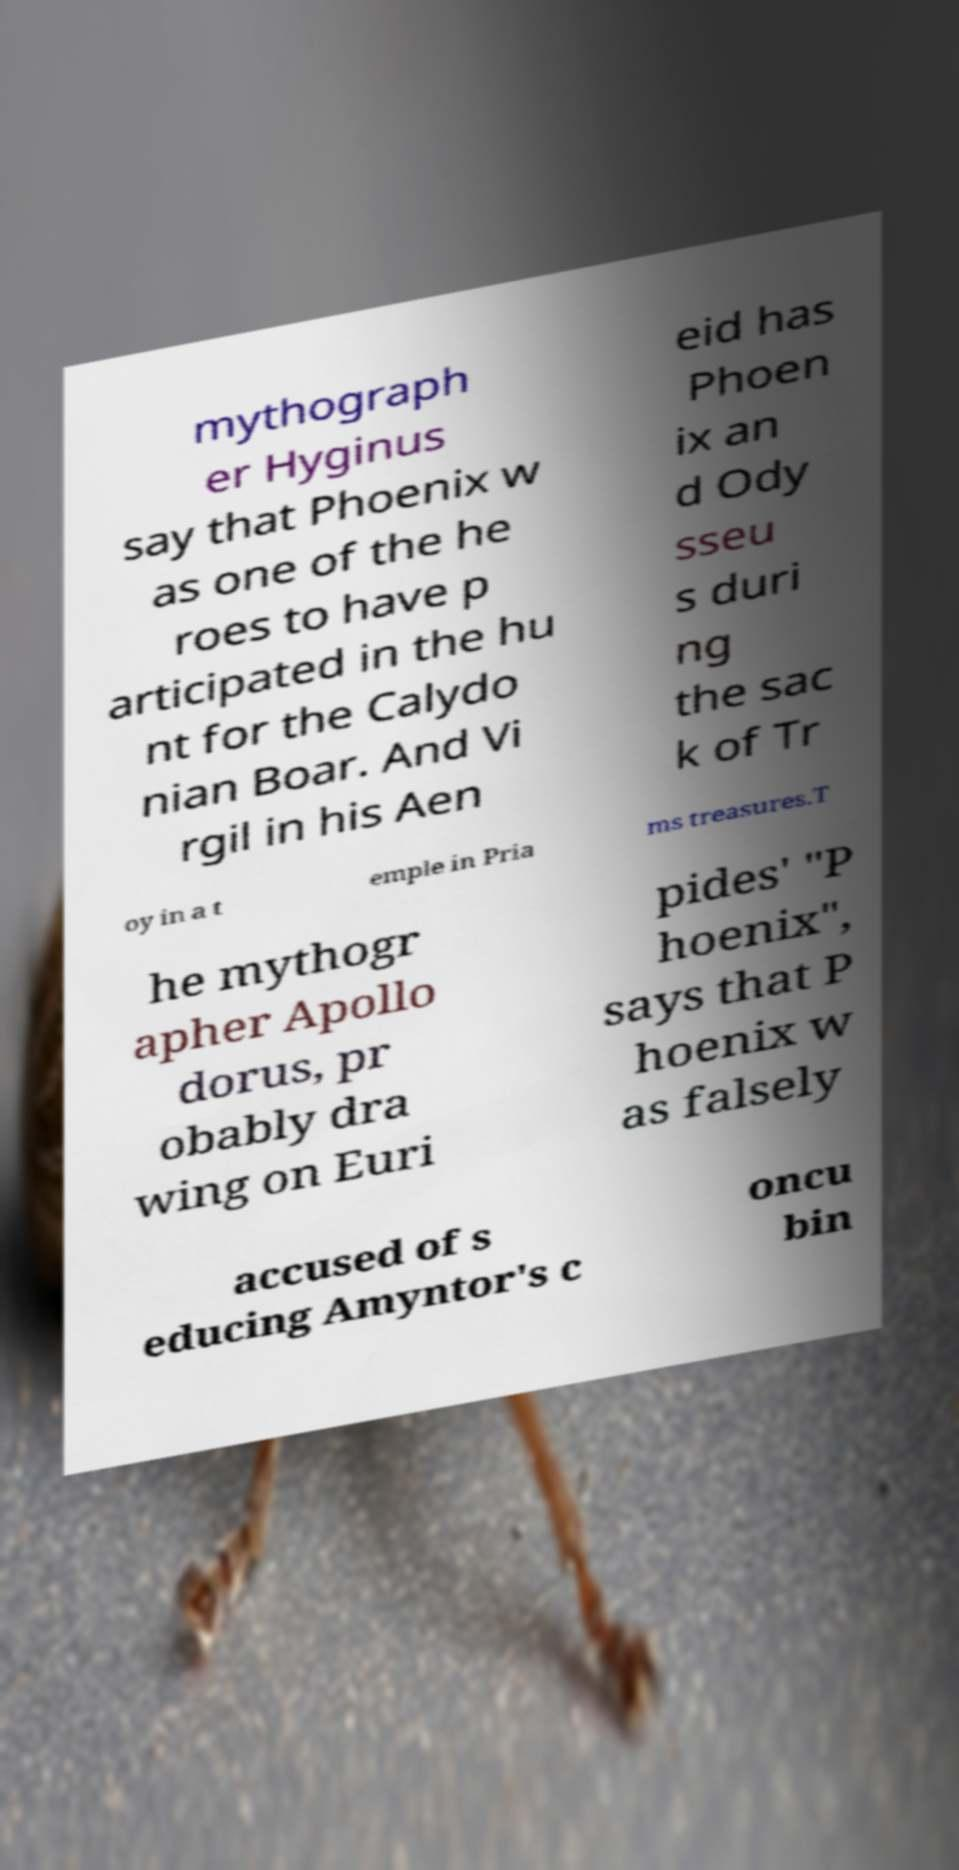Please identify and transcribe the text found in this image. mythograph er Hyginus say that Phoenix w as one of the he roes to have p articipated in the hu nt for the Calydo nian Boar. And Vi rgil in his Aen eid has Phoen ix an d Ody sseu s duri ng the sac k of Tr oy in a t emple in Pria ms treasures.T he mythogr apher Apollo dorus, pr obably dra wing on Euri pides' "P hoenix", says that P hoenix w as falsely accused of s educing Amyntor's c oncu bin 